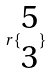Convert formula to latex. <formula><loc_0><loc_0><loc_500><loc_500>r \{ \begin{matrix} 5 \\ 3 \end{matrix} \}</formula> 